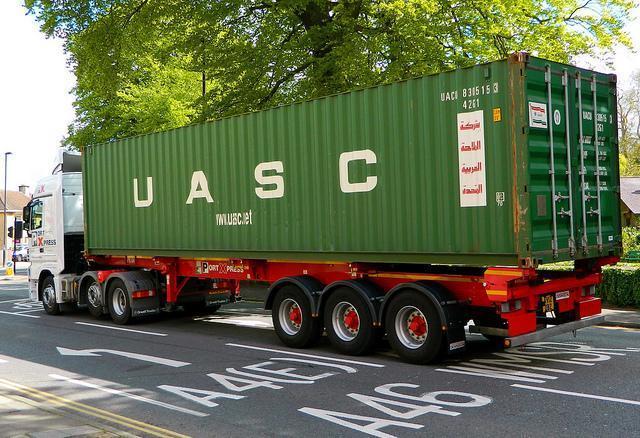How many people are holding news paper?
Give a very brief answer. 0. 